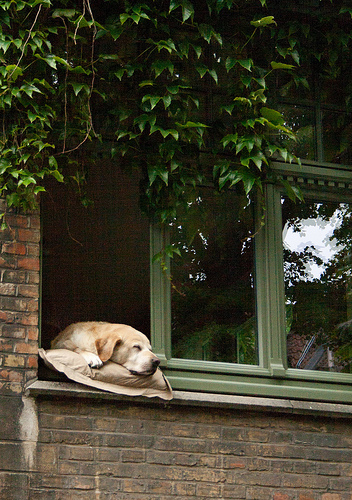<image>
Is the plant behind the window? No. The plant is not behind the window. From this viewpoint, the plant appears to be positioned elsewhere in the scene. Is the window behind the dog? No. The window is not behind the dog. From this viewpoint, the window appears to be positioned elsewhere in the scene. Is there a dog in the window? Yes. The dog is contained within or inside the window, showing a containment relationship. 